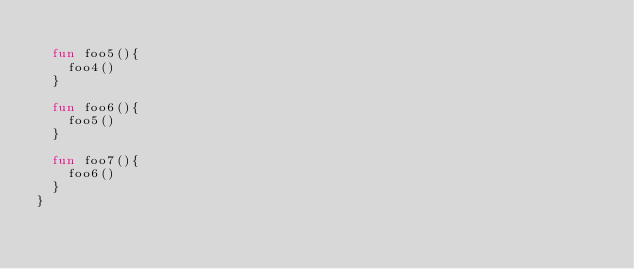Convert code to text. <code><loc_0><loc_0><loc_500><loc_500><_Kotlin_>
  fun foo5(){
    foo4()
  }

  fun foo6(){
    foo5()
  }

  fun foo7(){
    foo6()
  }
}</code> 